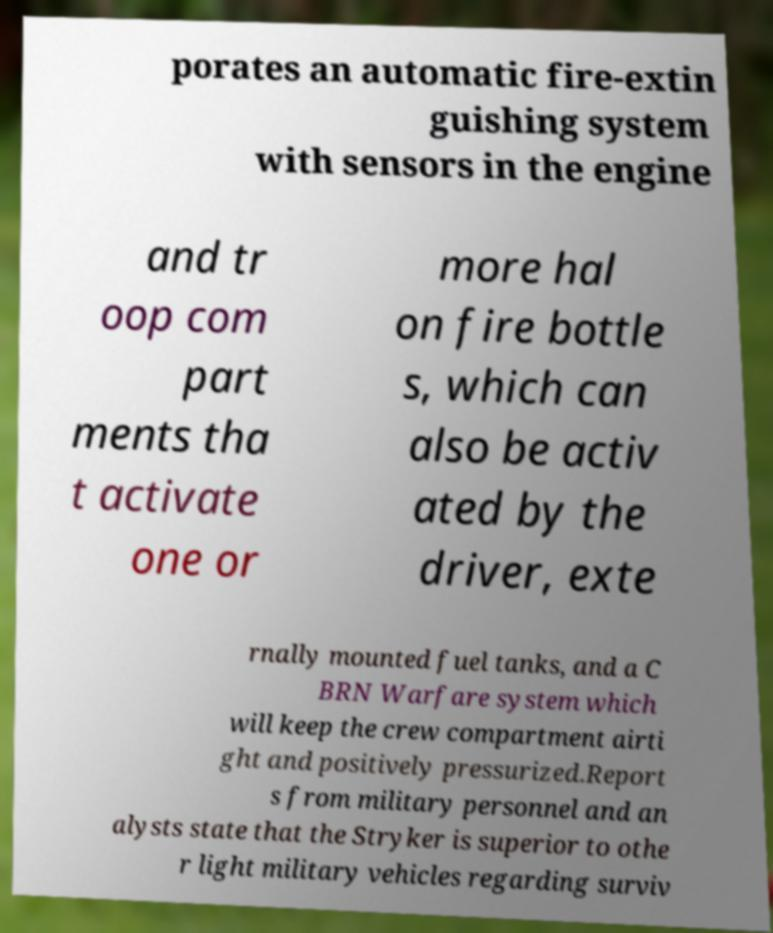Could you extract and type out the text from this image? porates an automatic fire-extin guishing system with sensors in the engine and tr oop com part ments tha t activate one or more hal on fire bottle s, which can also be activ ated by the driver, exte rnally mounted fuel tanks, and a C BRN Warfare system which will keep the crew compartment airti ght and positively pressurized.Report s from military personnel and an alysts state that the Stryker is superior to othe r light military vehicles regarding surviv 